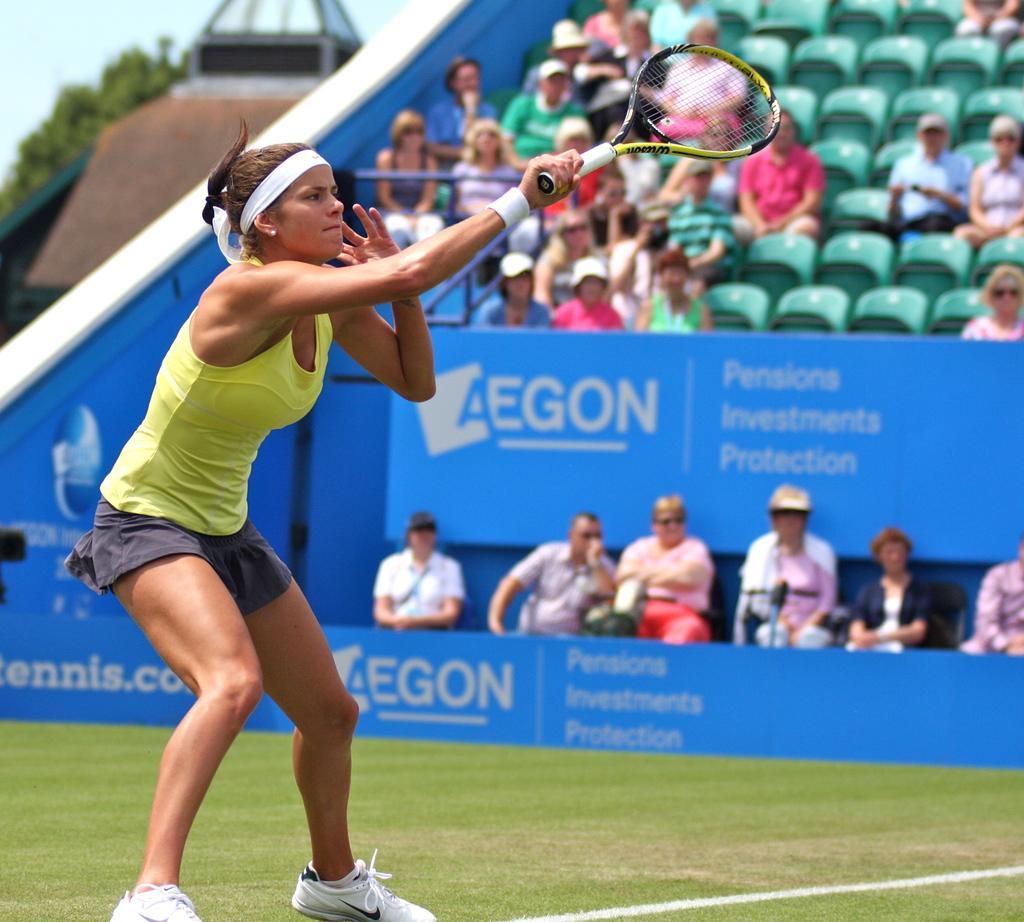How would you summarize this image in a sentence or two? In this image I see a woman who is on the grass and she is holding a bat in her hand. In the background I see people who are sitting on chairs. 